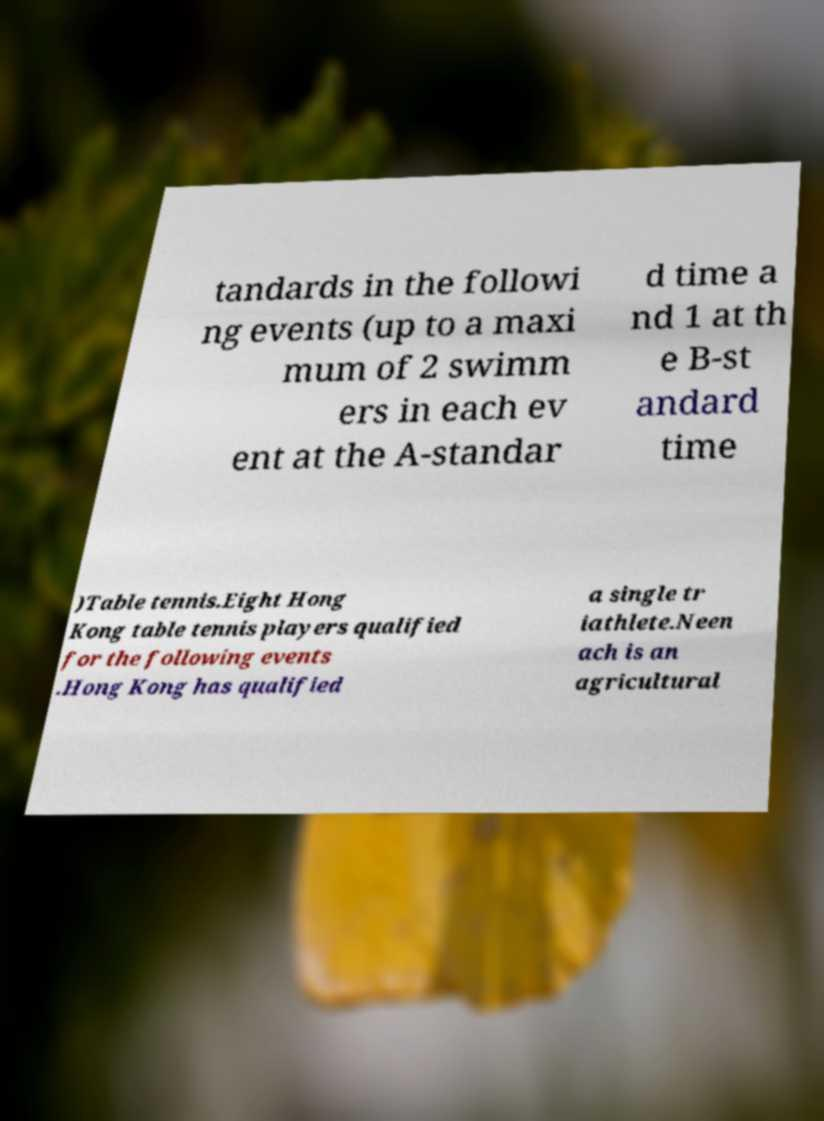For documentation purposes, I need the text within this image transcribed. Could you provide that? tandards in the followi ng events (up to a maxi mum of 2 swimm ers in each ev ent at the A-standar d time a nd 1 at th e B-st andard time )Table tennis.Eight Hong Kong table tennis players qualified for the following events .Hong Kong has qualified a single tr iathlete.Neen ach is an agricultural 